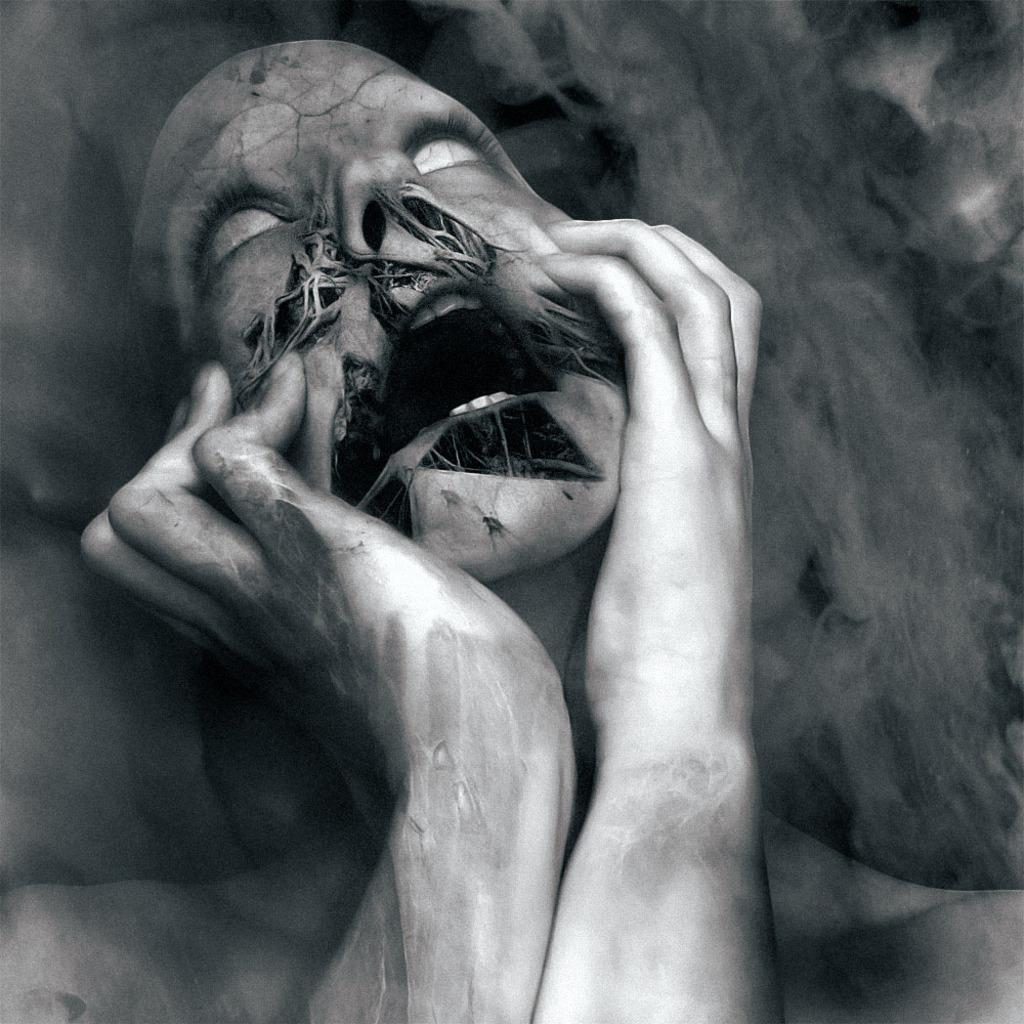Can you describe this image briefly? In the middle of this image, there is a person looking up and keeping both hands fingers on both cheeks. In the background, there is smoke. And the background is dark in color. 